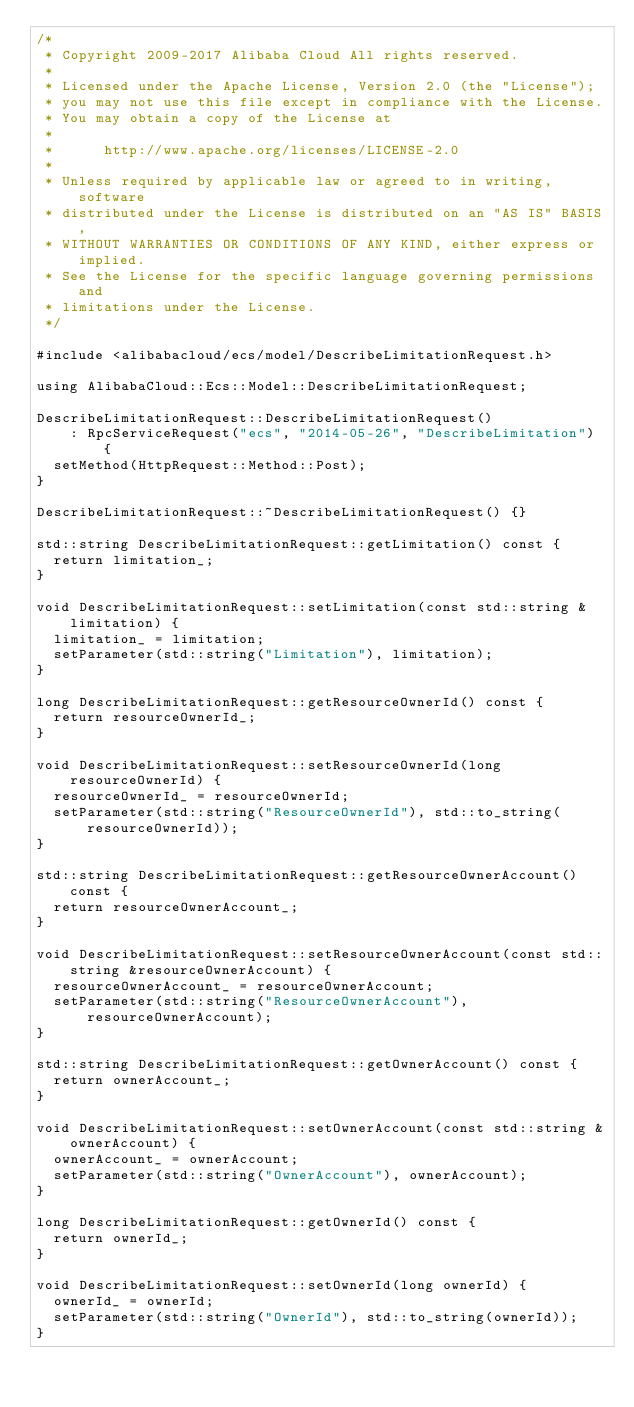Convert code to text. <code><loc_0><loc_0><loc_500><loc_500><_C++_>/*
 * Copyright 2009-2017 Alibaba Cloud All rights reserved.
 *
 * Licensed under the Apache License, Version 2.0 (the "License");
 * you may not use this file except in compliance with the License.
 * You may obtain a copy of the License at
 *
 *      http://www.apache.org/licenses/LICENSE-2.0
 *
 * Unless required by applicable law or agreed to in writing, software
 * distributed under the License is distributed on an "AS IS" BASIS,
 * WITHOUT WARRANTIES OR CONDITIONS OF ANY KIND, either express or implied.
 * See the License for the specific language governing permissions and
 * limitations under the License.
 */

#include <alibabacloud/ecs/model/DescribeLimitationRequest.h>

using AlibabaCloud::Ecs::Model::DescribeLimitationRequest;

DescribeLimitationRequest::DescribeLimitationRequest()
    : RpcServiceRequest("ecs", "2014-05-26", "DescribeLimitation") {
  setMethod(HttpRequest::Method::Post);
}

DescribeLimitationRequest::~DescribeLimitationRequest() {}

std::string DescribeLimitationRequest::getLimitation() const {
  return limitation_;
}

void DescribeLimitationRequest::setLimitation(const std::string &limitation) {
  limitation_ = limitation;
  setParameter(std::string("Limitation"), limitation);
}

long DescribeLimitationRequest::getResourceOwnerId() const {
  return resourceOwnerId_;
}

void DescribeLimitationRequest::setResourceOwnerId(long resourceOwnerId) {
  resourceOwnerId_ = resourceOwnerId;
  setParameter(std::string("ResourceOwnerId"), std::to_string(resourceOwnerId));
}

std::string DescribeLimitationRequest::getResourceOwnerAccount() const {
  return resourceOwnerAccount_;
}

void DescribeLimitationRequest::setResourceOwnerAccount(const std::string &resourceOwnerAccount) {
  resourceOwnerAccount_ = resourceOwnerAccount;
  setParameter(std::string("ResourceOwnerAccount"), resourceOwnerAccount);
}

std::string DescribeLimitationRequest::getOwnerAccount() const {
  return ownerAccount_;
}

void DescribeLimitationRequest::setOwnerAccount(const std::string &ownerAccount) {
  ownerAccount_ = ownerAccount;
  setParameter(std::string("OwnerAccount"), ownerAccount);
}

long DescribeLimitationRequest::getOwnerId() const {
  return ownerId_;
}

void DescribeLimitationRequest::setOwnerId(long ownerId) {
  ownerId_ = ownerId;
  setParameter(std::string("OwnerId"), std::to_string(ownerId));
}

</code> 